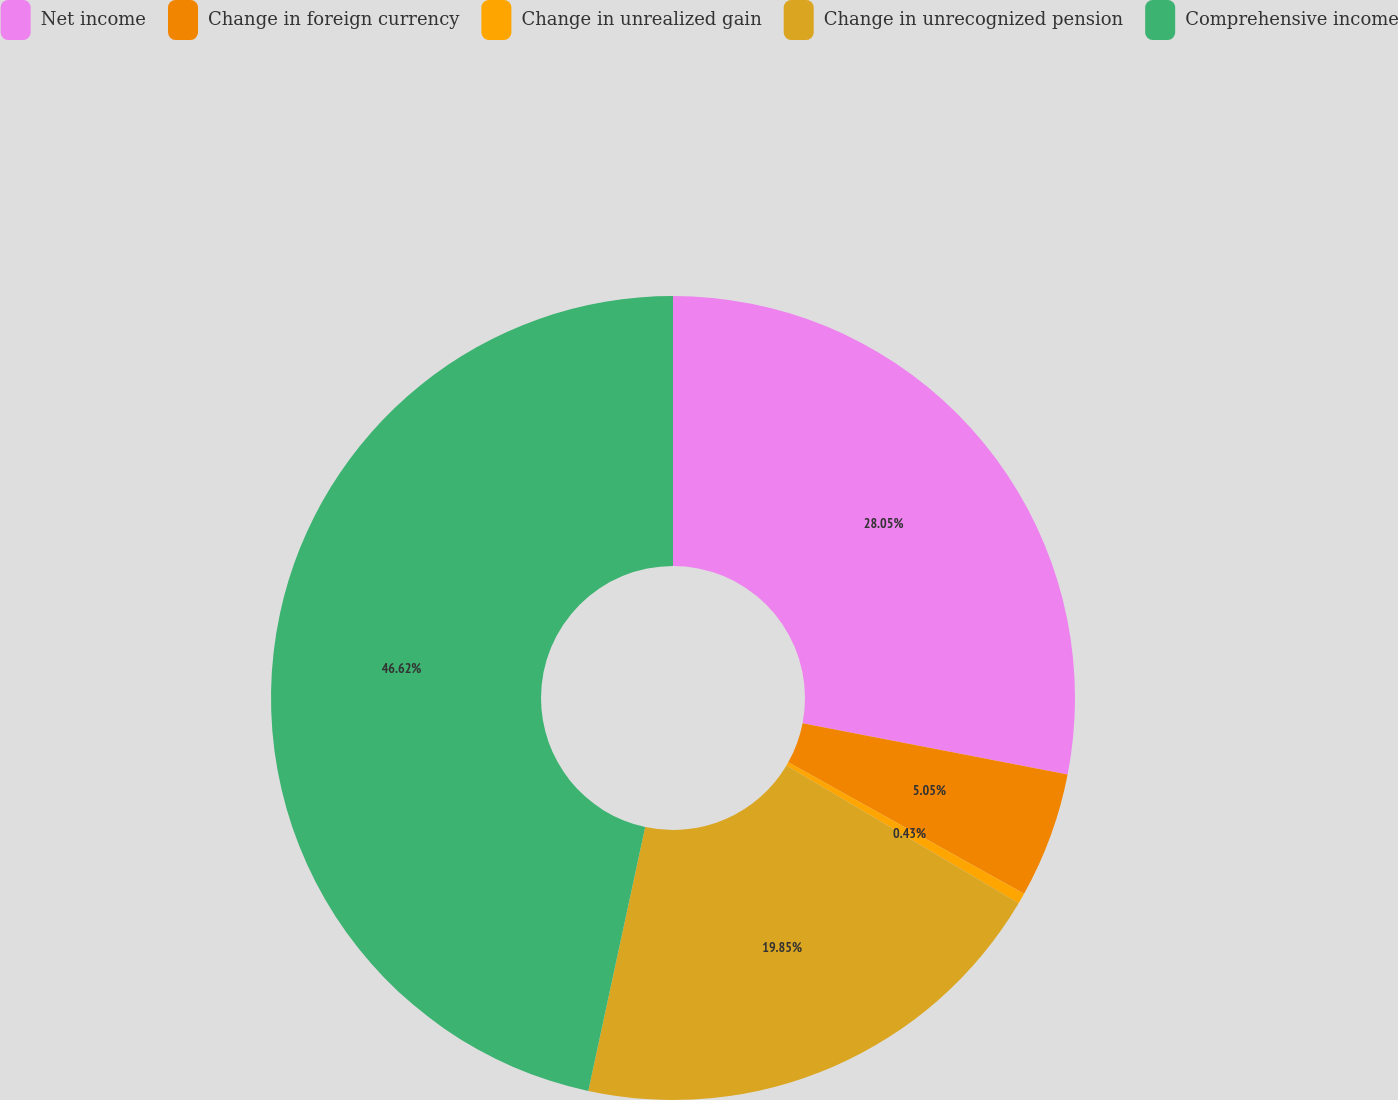Convert chart. <chart><loc_0><loc_0><loc_500><loc_500><pie_chart><fcel>Net income<fcel>Change in foreign currency<fcel>Change in unrealized gain<fcel>Change in unrecognized pension<fcel>Comprehensive income<nl><fcel>28.05%<fcel>5.05%<fcel>0.43%<fcel>19.85%<fcel>46.62%<nl></chart> 